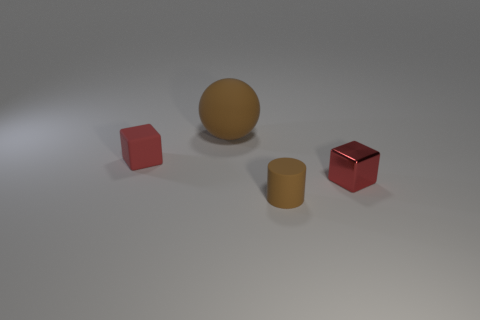How would the presence of additional light sources affect the shadows in the scene? Adding more light sources would create multiple shadows for each object, varying in direction and intensity. This would make the scene more complex as the overlapping shadows could alter the overall depth perception and contrast within the composition. 